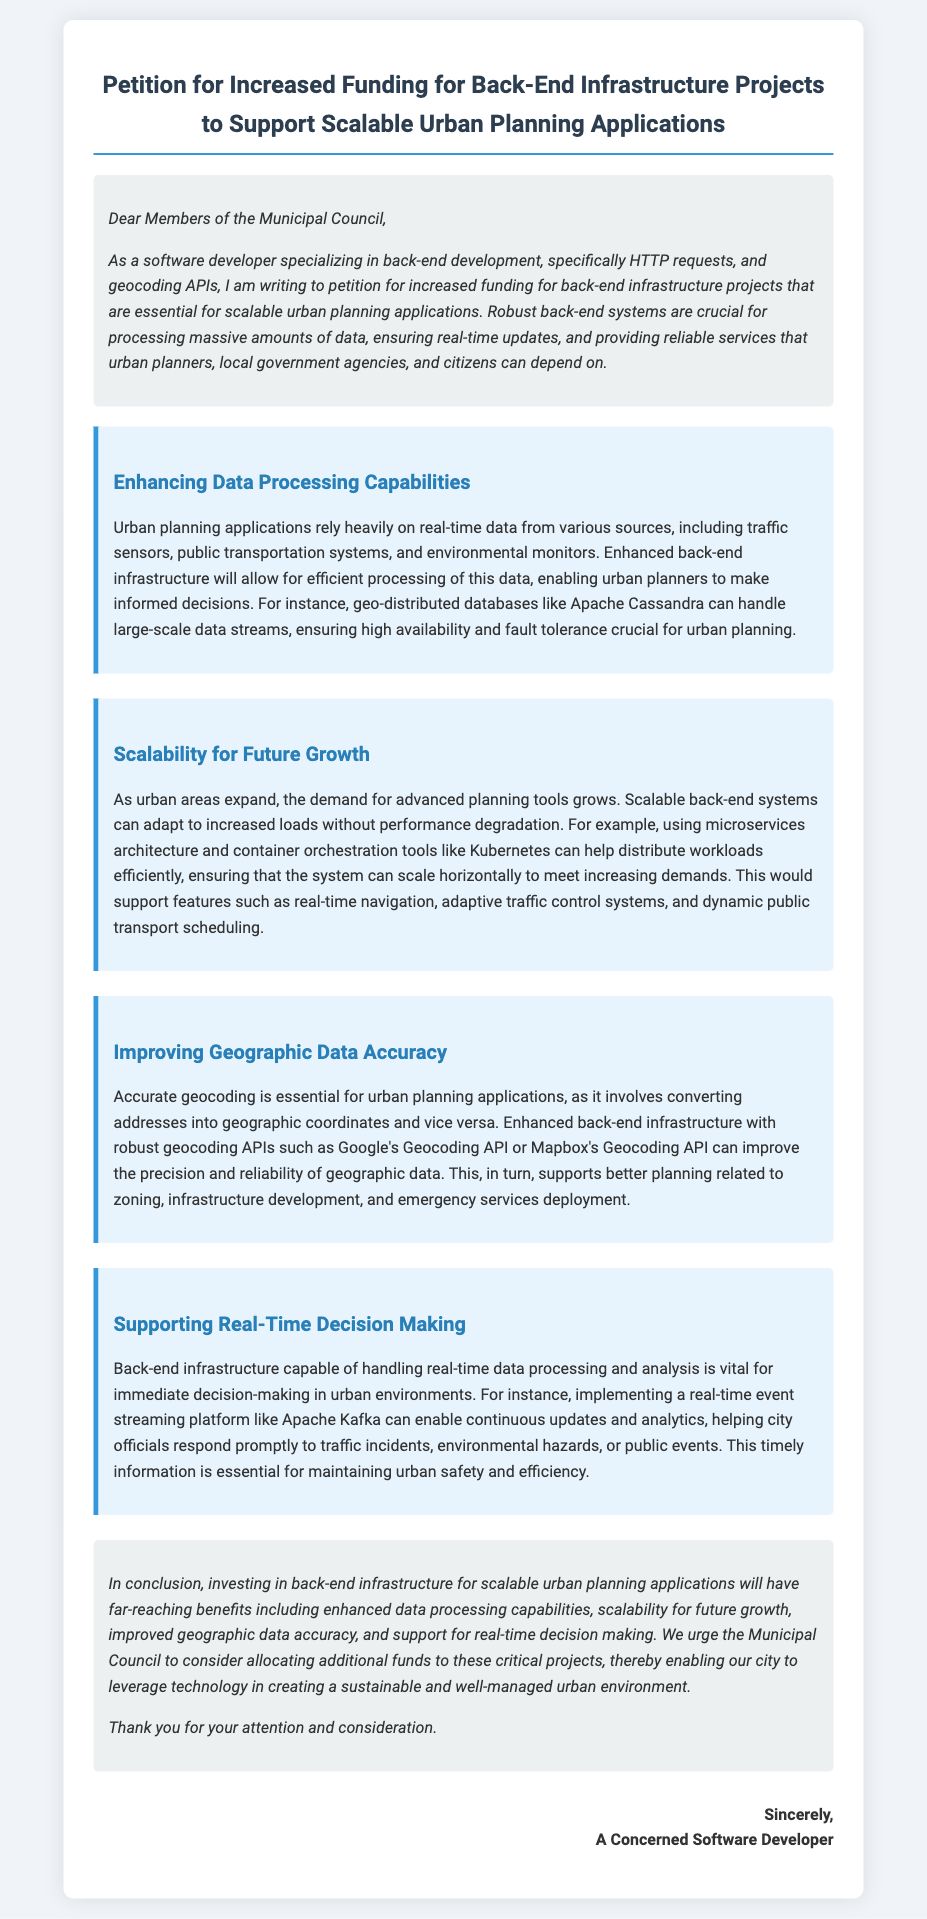What is the title of the petition? The title of the petition is stated at the top of the document.
Answer: Petition for Increased Funding for Back-End Infrastructure Projects to Support Scalable Urban Planning Applications Who is the petition addressed to? The petition is directed towards specific members as indicated in the introduction.
Answer: Members of the Municipal Council What is a primary technology mentioned for handling large-scale data streams? The document specifies a particular technology used for this purpose within the text.
Answer: Apache Cassandra What infrastructure capability is emphasized for urban planning applications? The petition highlights a specific capability that is crucial for the applications discussed.
Answer: Real-time data processing What is one benefit of investing in back-end infrastructure according to the conclusion? The conclusion lists various benefits of the proposed investment in back-end infrastructure.
Answer: Enhanced data processing capabilities Which real-time event streaming platform is mentioned in the petition? The petition specifically names a platform relevant for real-time data handling.
Answer: Apache Kafka What is a key improvement area for geographic data mentioned? The petition points out a specific aspect of geographic data that needs enhancement.
Answer: Geographic data accuracy How does the petition propose to support future urban growth? The document explains a strategy related to scalability in systems for urban areas.
Answer: Scalability for future growth 